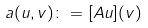<formula> <loc_0><loc_0><loc_500><loc_500>a ( u , v ) \colon = [ A u ] ( v )</formula> 